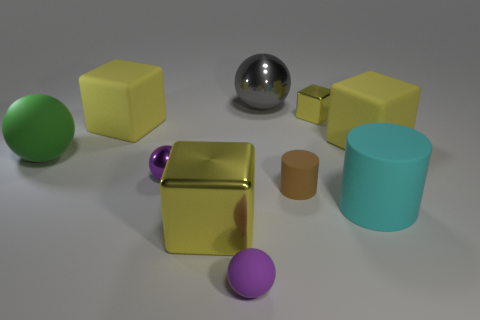Subtract all yellow blocks. How many were subtracted if there are2yellow blocks left? 2 Subtract 1 blocks. How many blocks are left? 3 Subtract all red blocks. Subtract all yellow cylinders. How many blocks are left? 4 Subtract all cylinders. How many objects are left? 8 Subtract 0 yellow cylinders. How many objects are left? 10 Subtract all large green objects. Subtract all cyan metallic blocks. How many objects are left? 9 Add 1 big gray metal balls. How many big gray metal balls are left? 2 Add 7 small blue metal cylinders. How many small blue metal cylinders exist? 7 